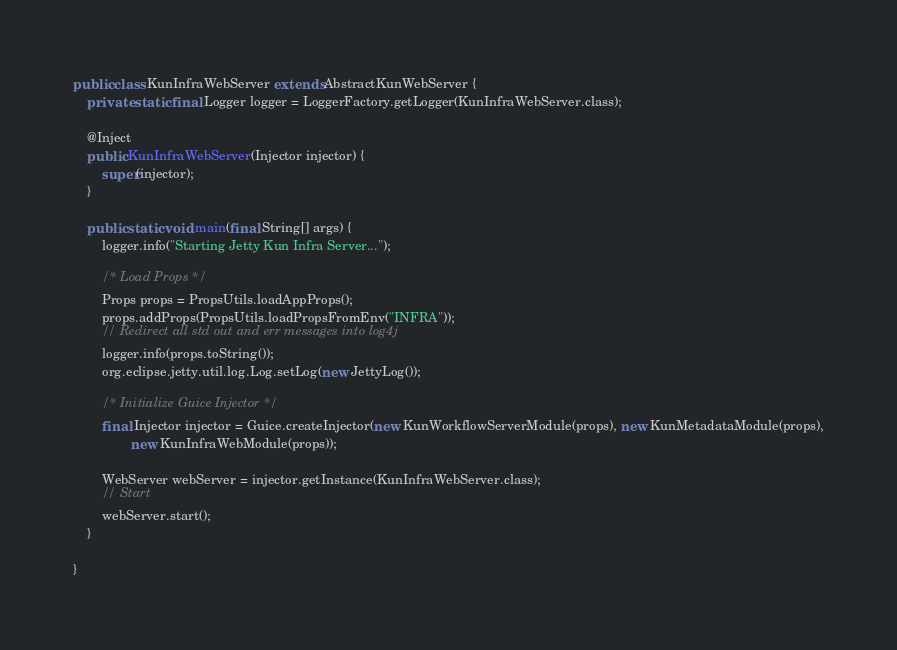Convert code to text. <code><loc_0><loc_0><loc_500><loc_500><_Java_>public class KunInfraWebServer extends AbstractKunWebServer {
    private static final Logger logger = LoggerFactory.getLogger(KunInfraWebServer.class);

    @Inject
    public KunInfraWebServer(Injector injector) {
        super(injector);
    }

    public static void main(final String[] args) {
        logger.info("Starting Jetty Kun Infra Server...");

        /* Load Props */
        Props props = PropsUtils.loadAppProps();
        props.addProps(PropsUtils.loadPropsFromEnv("INFRA"));
        // Redirect all std out and err messages into log4j
        logger.info(props.toString());
        org.eclipse.jetty.util.log.Log.setLog(new JettyLog());

        /* Initialize Guice Injector */
        final Injector injector = Guice.createInjector(new KunWorkflowServerModule(props), new KunMetadataModule(props),
                new KunInfraWebModule(props));

        WebServer webServer = injector.getInstance(KunInfraWebServer.class);
        // Start
        webServer.start();
    }

}
</code> 